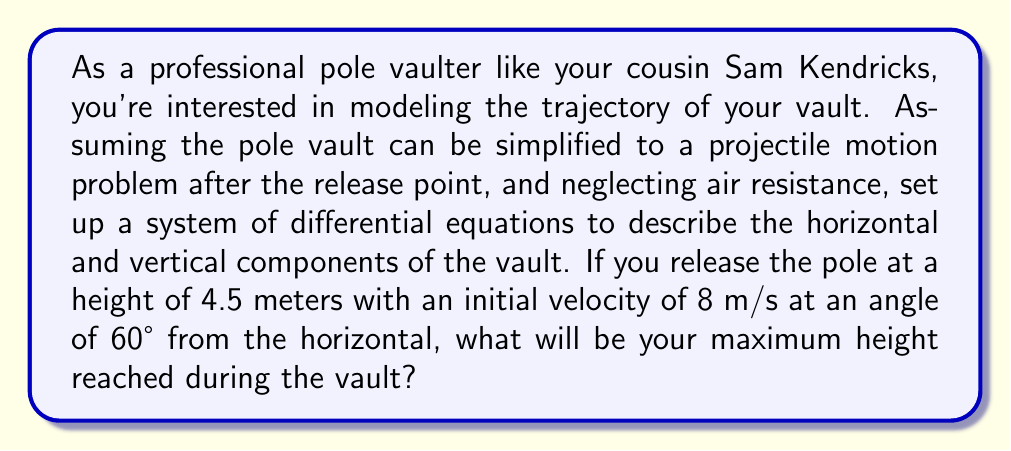Could you help me with this problem? Let's approach this step-by-step:

1) First, we need to set up our coordinate system. Let's use x for horizontal distance and y for vertical distance, with the origin at the point of release.

2) The differential equations describing the motion are:

   $$\frac{d^2x}{dt^2} = 0$$
   $$\frac{d^2y}{dt^2} = -g$$

   Where g is the acceleration due to gravity (9.8 m/s^2).

3) We can integrate these equations once to get the velocity components:

   $$\frac{dx}{dt} = v_0 \cos\theta$$
   $$\frac{dy}{dt} = v_0 \sin\theta - gt$$

   Where $v_0$ is the initial velocity and $\theta$ is the angle from the horizontal.

4) Given information:
   - Initial height: $y_0 = 4.5$ m
   - Initial velocity: $v_0 = 8$ m/s
   - Release angle: $\theta = 60°$

5) To find the maximum height, we need to find when the vertical velocity becomes zero:

   $$0 = v_0 \sin\theta - gt$$
   $$t = \frac{v_0 \sin\theta}{g}$$

6) Substituting our values:

   $$t = \frac{8 \sin(60°)}{9.8} \approx 0.71 \text{ seconds}$$

7) Now we can find the maximum height by integrating the vertical velocity equation:

   $$y = y_0 + v_0 \sin\theta \cdot t - \frac{1}{2}gt^2$$

8) Substituting our values:

   $$y = 4.5 + 8 \sin(60°) \cdot 0.71 - \frac{1}{2} \cdot 9.8 \cdot 0.71^2$$
   $$y = 4.5 + 4.91 - 2.47 = 6.94 \text{ meters}$$

Therefore, the maximum height reached during the vault is approximately 6.94 meters.
Answer: The maximum height reached during the vault is approximately 6.94 meters. 